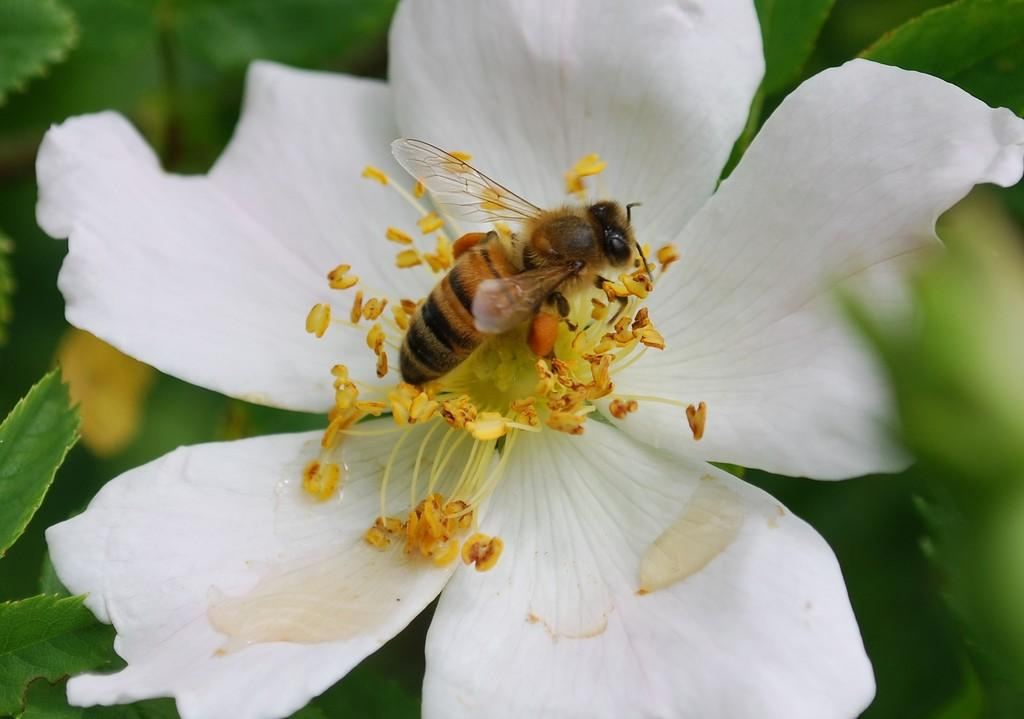What insect can be seen in the image? There is a bee in the image. Where is the bee located in the image? The bee is on a flower in the image. What other plant elements are visible in the image? There are leaves in the image. How does the bee comfort the person in the image? There is no person present in the image, and the bee is not shown providing comfort. 